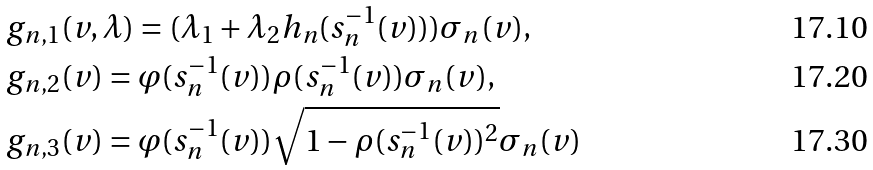Convert formula to latex. <formula><loc_0><loc_0><loc_500><loc_500>& g _ { n , 1 } ( v , \lambda ) = ( \lambda _ { 1 } + \lambda _ { 2 } h _ { n } ( s _ { n } ^ { - 1 } ( v ) ) ) \sigma _ { n } ( v ) , \\ & g _ { n , 2 } ( v ) = \varphi ( s _ { n } ^ { - 1 } ( v ) ) \rho ( s _ { n } ^ { - 1 } ( v ) ) \sigma _ { n } ( v ) , \\ & g _ { n , 3 } ( v ) = \varphi ( s _ { n } ^ { - 1 } ( v ) ) \sqrt { 1 - \rho ( s _ { n } ^ { - 1 } ( v ) ) ^ { 2 } } \sigma _ { n } ( v )</formula> 